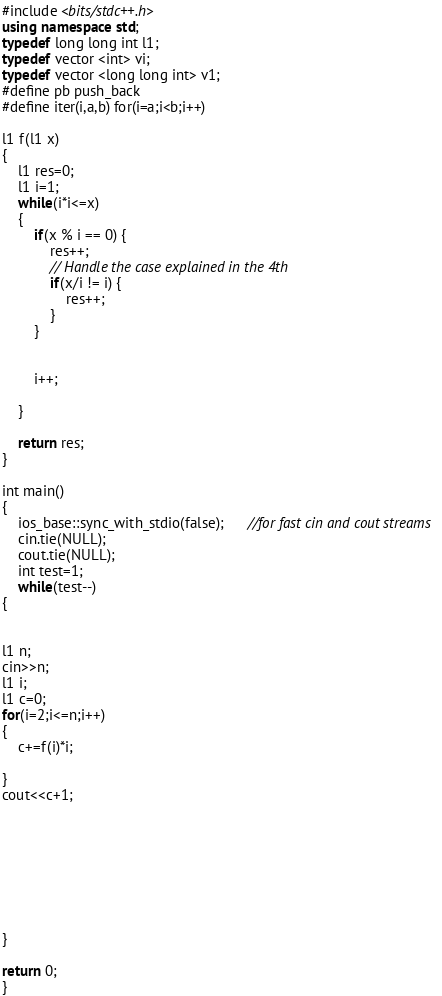Convert code to text. <code><loc_0><loc_0><loc_500><loc_500><_C++_>#include <bits/stdc++.h>
using namespace std;
typedef long long int l1;
typedef vector <int> vi;
typedef vector <long long int> v1;
#define pb push_back
#define iter(i,a,b) for(i=a;i<b;i++)

l1 f(l1 x)
{
    l1 res=0;
    l1 i=1;
    while(i*i<=x)
    {
        if(x % i == 0) {
            res++;
            // Handle the case explained in the 4th
            if(x/i != i) {
                res++;
            }
        }
        
        
        i++;
            
    }
    
    return res;
}

int main()
{
    ios_base::sync_with_stdio(false);      //for fast cin and cout streams
    cin.tie(NULL);
    cout.tie(NULL);
    int test=1;
    while(test--)
{


l1 n;
cin>>n;
l1 i;
l1 c=0;
for(i=2;i<=n;i++)
{
	c+=f(i)*i;

}
cout<<c+1;








}

return 0;
}




</code> 